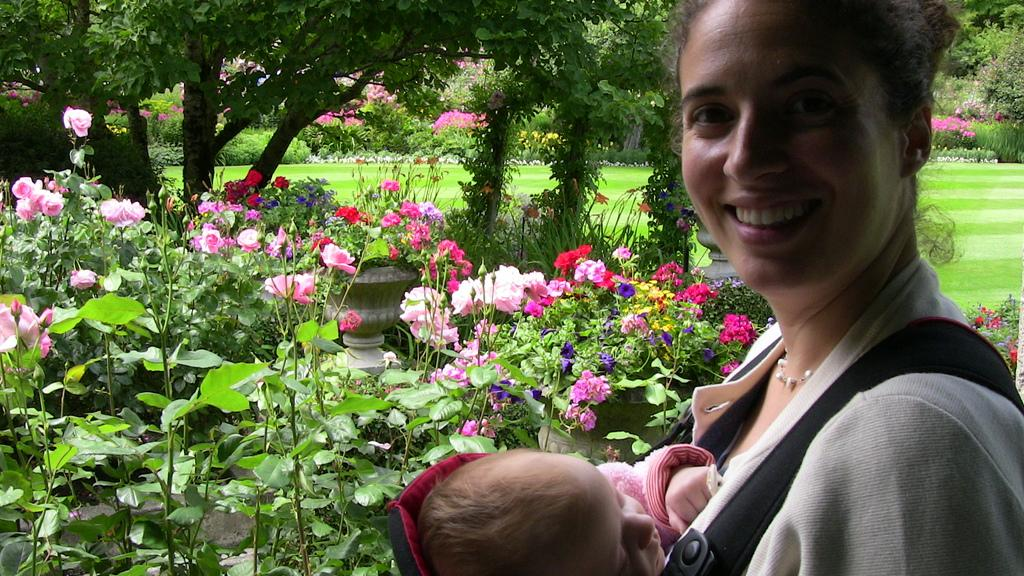Who is the main subject in the image? There is a woman in the image. What is the woman doing in the image? The woman is carrying a baby in a bag on her shoulders. What can be seen in the background of the image? There are plants with flowers, trees, and grass in the background of the image. What type of rings can be seen on the woman's fingers in the image? There are no rings visible on the woman's fingers in the image. What verse is being recited by the baby in the bag? The baby is not reciting any verse in the image; they are simply being carried by the woman. 